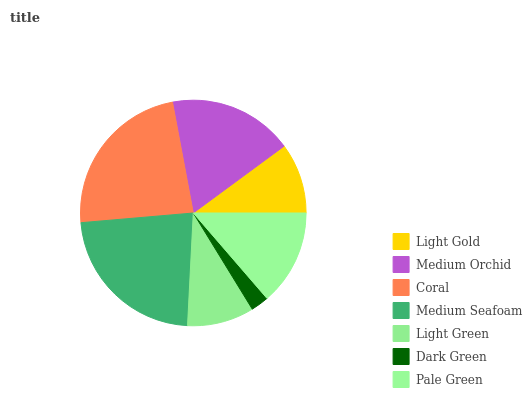Is Dark Green the minimum?
Answer yes or no. Yes. Is Coral the maximum?
Answer yes or no. Yes. Is Medium Orchid the minimum?
Answer yes or no. No. Is Medium Orchid the maximum?
Answer yes or no. No. Is Medium Orchid greater than Light Gold?
Answer yes or no. Yes. Is Light Gold less than Medium Orchid?
Answer yes or no. Yes. Is Light Gold greater than Medium Orchid?
Answer yes or no. No. Is Medium Orchid less than Light Gold?
Answer yes or no. No. Is Pale Green the high median?
Answer yes or no. Yes. Is Pale Green the low median?
Answer yes or no. Yes. Is Medium Orchid the high median?
Answer yes or no. No. Is Coral the low median?
Answer yes or no. No. 